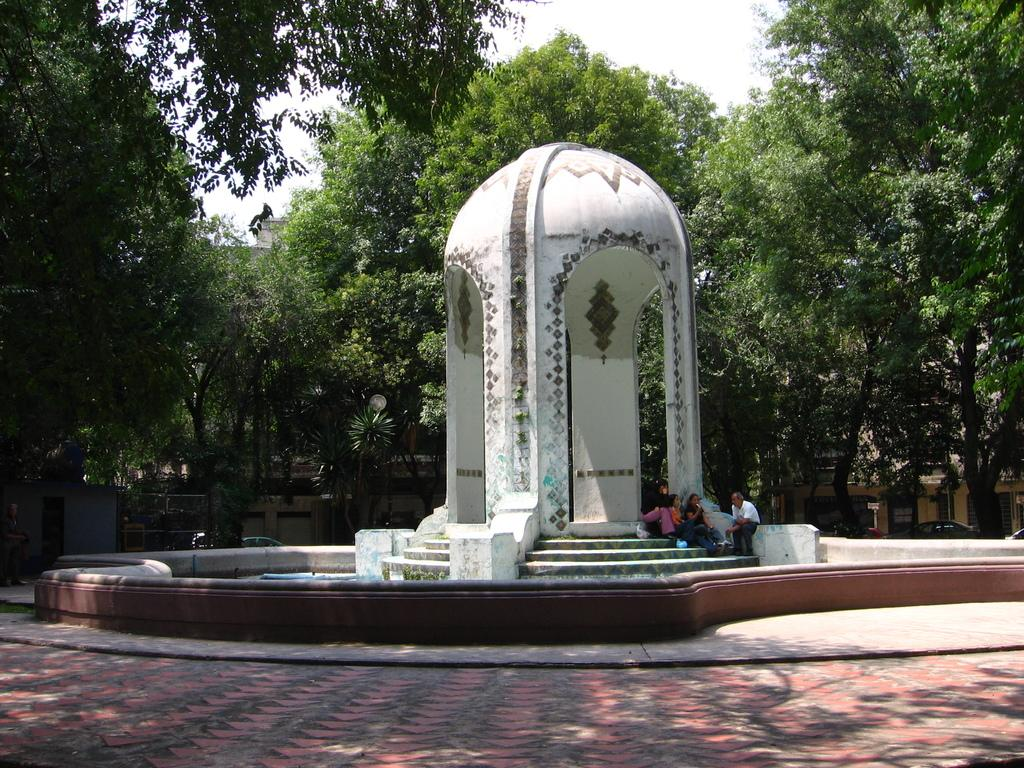What type of structure is depicted in the image? There is an arch design construction in the image. Are there any people present in the image? Yes, there are people sitting in the image. What are the people wearing? The people are wearing clothes. What architectural feature is visible in the image? There are stairs in the image. What type of path is present in the image? There is a footpath in the image. What type of vegetation is visible in the image? There are trees in the image. What part of the natural environment is visible in the image? The sky is visible in the image. Can you tell me how many snakes are slithering on the footpath in the image? There are no snakes present in the image; the footpath is clear. What type of boundary is visible in the image? There is no specific boundary mentioned or visible in the image. 